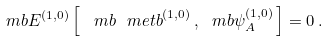<formula> <loc_0><loc_0><loc_500><loc_500>\ m b { E } ^ { ( 1 , 0 ) } \left [ \, \ m b { \ m e t b } ^ { ( 1 , 0 ) } \, , \ m b { \psi } _ { A } ^ { ( 1 , 0 ) } \, \right ] = 0 \, .</formula> 